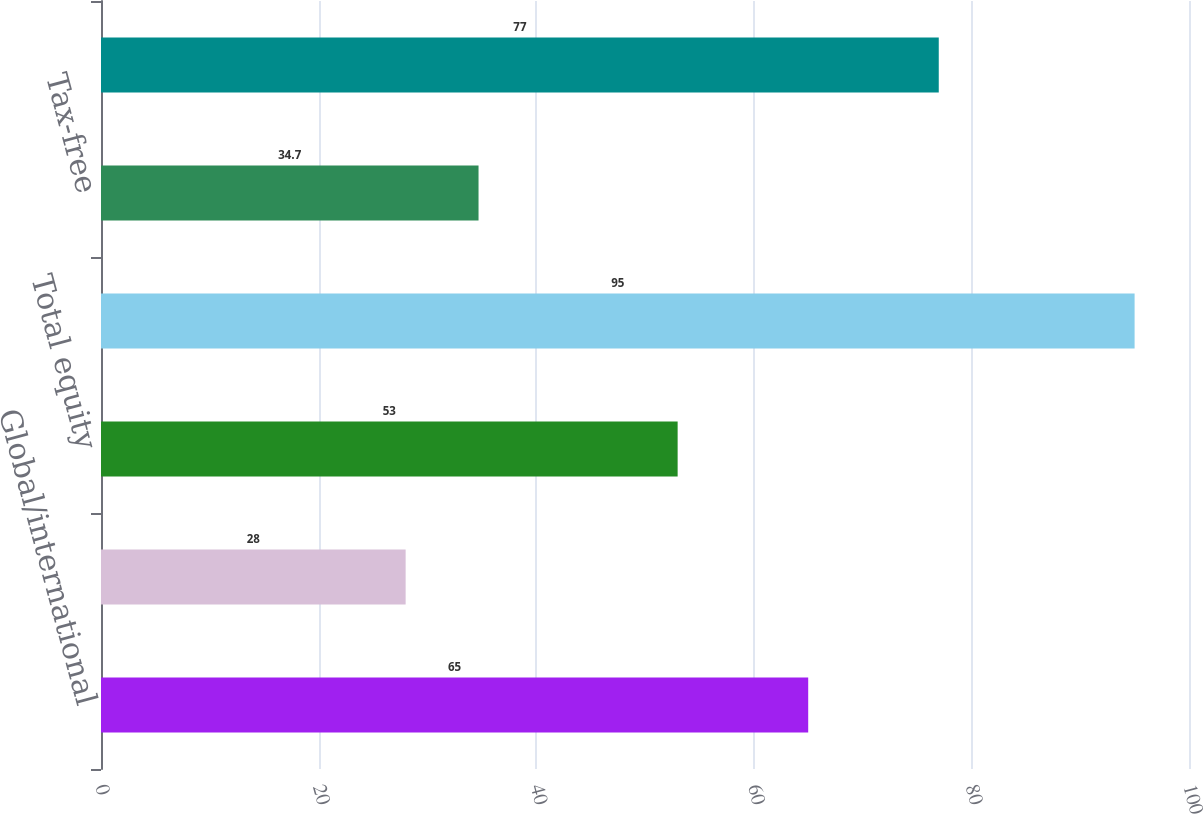Convert chart. <chart><loc_0><loc_0><loc_500><loc_500><bar_chart><fcel>Global/international<fcel>United States<fcel>Total equity<fcel>Hybrid<fcel>Tax-free<fcel>Total fixed-income<nl><fcel>65<fcel>28<fcel>53<fcel>95<fcel>34.7<fcel>77<nl></chart> 